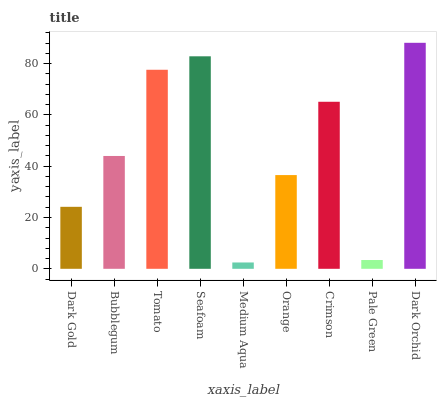Is Bubblegum the minimum?
Answer yes or no. No. Is Bubblegum the maximum?
Answer yes or no. No. Is Bubblegum greater than Dark Gold?
Answer yes or no. Yes. Is Dark Gold less than Bubblegum?
Answer yes or no. Yes. Is Dark Gold greater than Bubblegum?
Answer yes or no. No. Is Bubblegum less than Dark Gold?
Answer yes or no. No. Is Bubblegum the high median?
Answer yes or no. Yes. Is Bubblegum the low median?
Answer yes or no. Yes. Is Medium Aqua the high median?
Answer yes or no. No. Is Orange the low median?
Answer yes or no. No. 